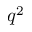Convert formula to latex. <formula><loc_0><loc_0><loc_500><loc_500>q ^ { 2 }</formula> 